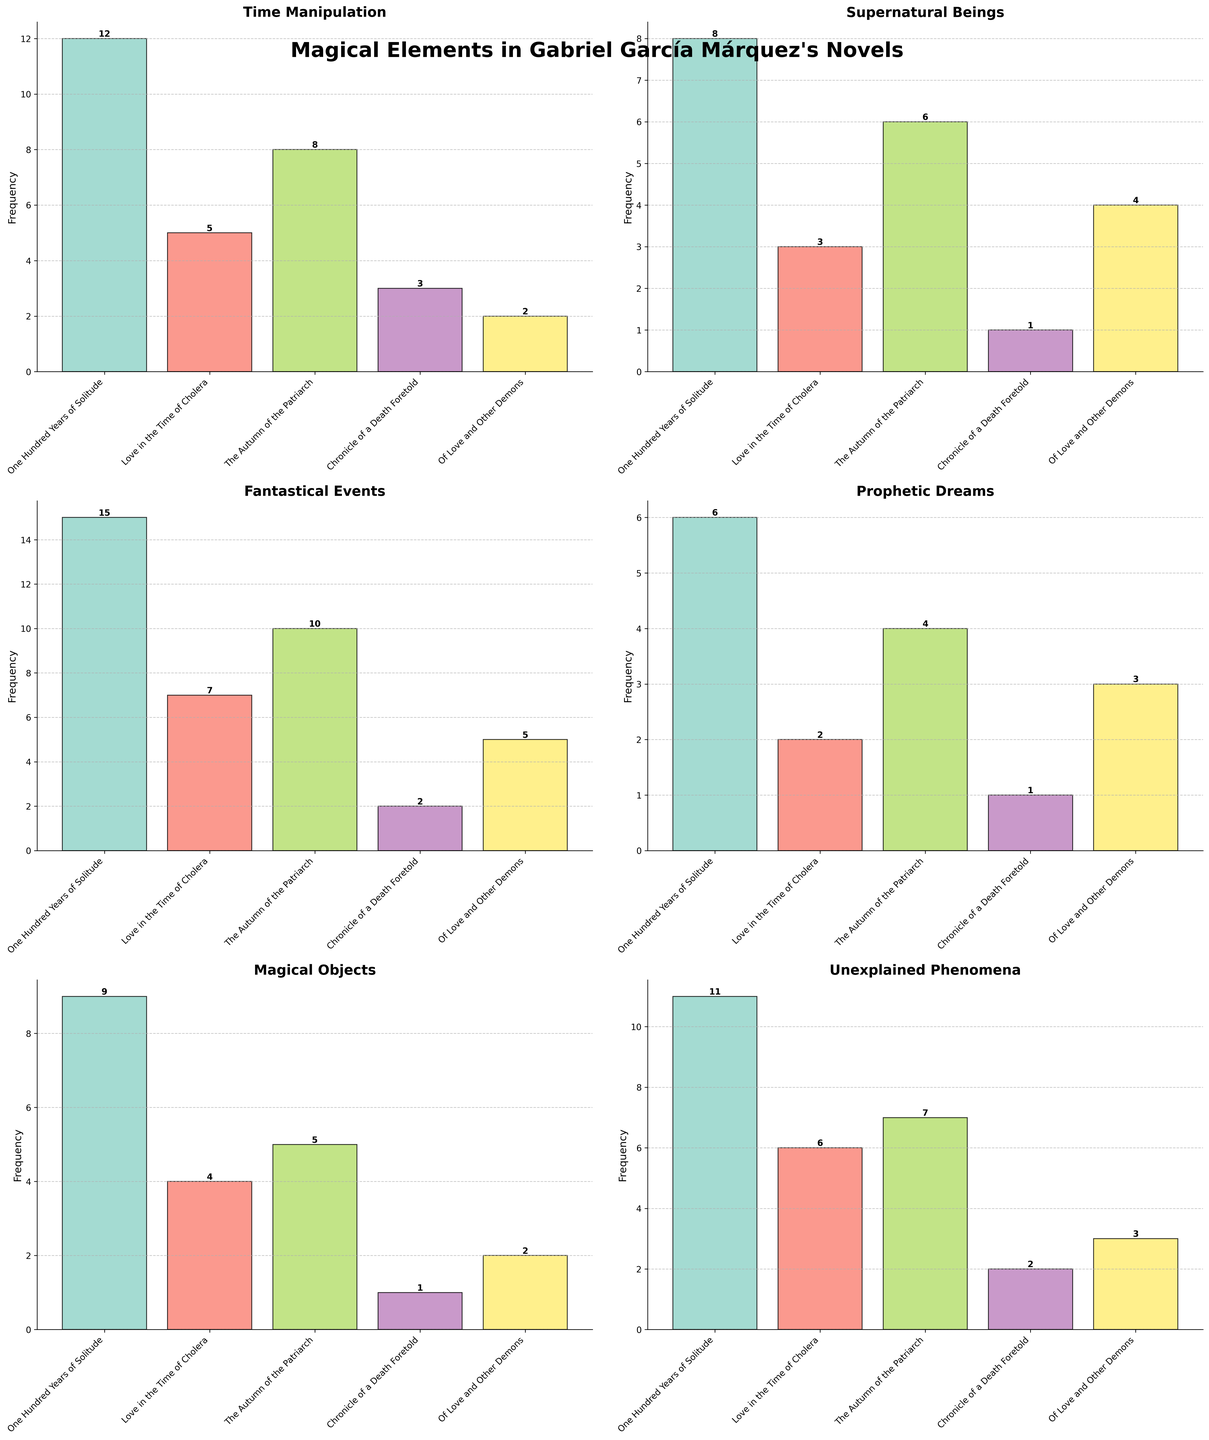Which novel has the highest count of 'Time Manipulation' magical elements? The subplot for 'Time Manipulation' shows the count of these elements per novel. The highest bar corresponds to 'One Hundred Years of Solitude'.
Answer: One Hundred Years of Solitude Out of all the novels, which one features 'Fantastical Events' the most? Look at the subplot titled 'Fantastical Events' and compare the heights of the bars. The tallest bar represents 'One Hundred Years of Solitude'.
Answer: One Hundred Years of Solitude Which type of magical element appears most frequently in 'Chronicle of a Death Foretold'? Sum the values of all the magical elements for 'Chronicle of a Death Foretold' and check which type is highest. 'Fantastical Events' has the highest count with 2 occurrences.
Answer: Fantastical Events Between 'Supernatural Beings' and 'Magical Objects', which has a higher total count across all novels? Sum the counts for 'Supernatural Beings' and 'Magical Objects' across all novels. Supernatural Beings: 8+3+6+1+4=22. Magical Objects: 9+4+5+1+2=21.
Answer: Supernatural Beings How many more times does 'Magical Objects' appear in 'One Hundred Years of Solitude' compared to 'Chronicle of a Death Foretold'? Subtract the count of 'Magical Objects' in 'Chronicle of a Death Foretold' from its count in 'One Hundred Years of Solitude'. 9 - 1 = 8
Answer: 8 What is the average occurrence of 'Prophetic Dreams' across all the novels? Add all the counts for 'Prophetic Dreams' and divide by the number of novels: (6+2+4+1+3)/5 = 3.2
Answer: 3.2 In which novel does the 'Unexplained Phenomena' count equal to that of 'Magical Objects'? Compare the 'Unexplained Phenomena' subplot against 'Magical Objects'. Both have a count of 1 in 'Chronicle of a Death Foretold'.
Answer: Chronicle of a Death Foretold Which novel and magical element combination has the lowest occurrence? Look for the subplot with the smallest values. 'Levitation' in 'Love in the Time of Cholera', 'Chronicle of a Death Foretold', and 'Invisibility' in 'Chronicle of a Death Foretold' all have 0 counts.
Answer: Levitation in Chronicle of a Death Foretold What is the difference in counts of 'Weather Control' between 'One Hundred Years of Solitude' and 'Of Love and Other Demons'? Subtract the 'Weather Control' count in 'Of Love and Other Demons' from its count in 'One Hundred Years of Solitude'. 4 - 0 = 4
Answer: 4 Which novel has a total count of magical elements equal to 29? Add the counts of all magical elements for each novel and see which one sums to 29. 'One Hundred Years of Solitude' totals 29.
Answer: One Hundred Years of Solitude 